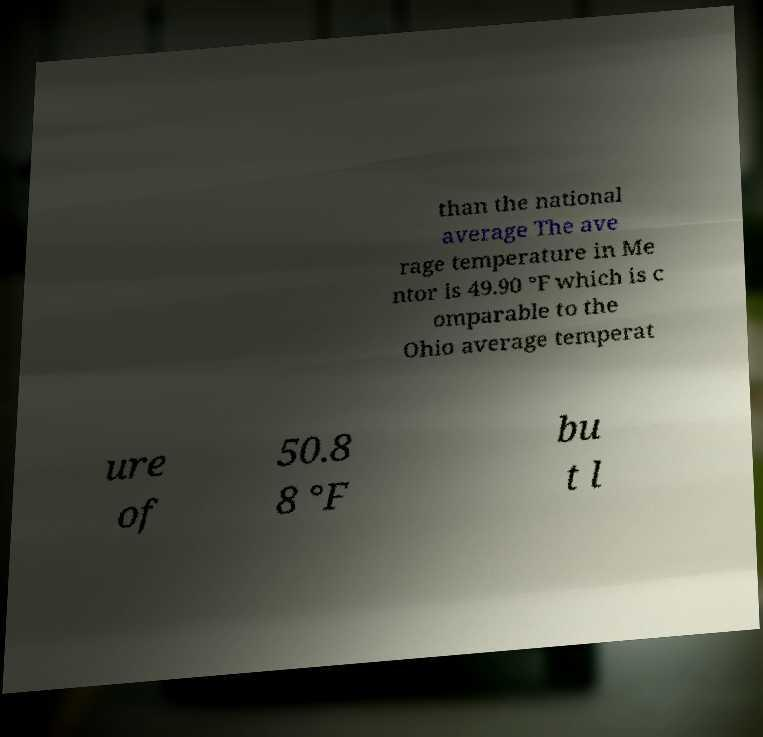Please read and relay the text visible in this image. What does it say? than the national average The ave rage temperature in Me ntor is 49.90 °F which is c omparable to the Ohio average temperat ure of 50.8 8 °F bu t l 